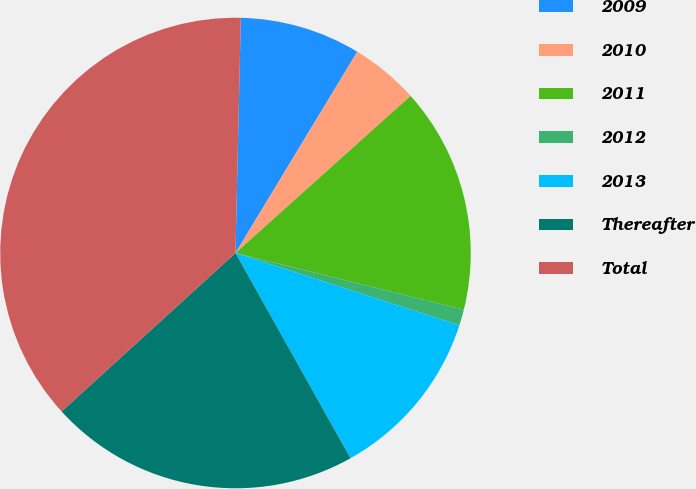Convert chart to OTSL. <chart><loc_0><loc_0><loc_500><loc_500><pie_chart><fcel>2009<fcel>2010<fcel>2011<fcel>2012<fcel>2013<fcel>Thereafter<fcel>Total<nl><fcel>8.3%<fcel>4.7%<fcel>15.51%<fcel>1.1%<fcel>11.9%<fcel>21.37%<fcel>37.12%<nl></chart> 